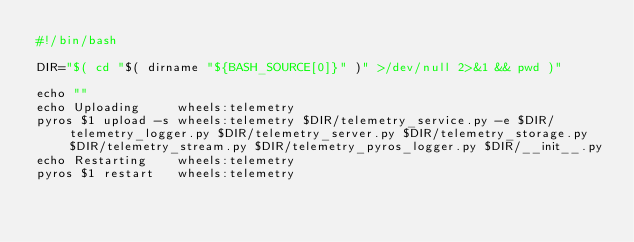<code> <loc_0><loc_0><loc_500><loc_500><_Bash_>#!/bin/bash

DIR="$( cd "$( dirname "${BASH_SOURCE[0]}" )" >/dev/null 2>&1 && pwd )"

echo ""
echo Uploading     wheels:telemetry
pyros $1 upload -s wheels:telemetry $DIR/telemetry_service.py -e $DIR/telemetry_logger.py $DIR/telemetry_server.py $DIR/telemetry_storage.py $DIR/telemetry_stream.py $DIR/telemetry_pyros_logger.py $DIR/__init__.py
echo Restarting    wheels:telemetry
pyros $1 restart   wheels:telemetry
</code> 